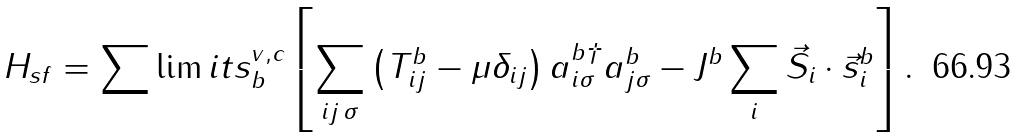<formula> <loc_0><loc_0><loc_500><loc_500>H _ { s f } = \sum \lim i t s _ { b } ^ { v , c } \left [ \sum _ { i j \, \sigma } \left ( T _ { i j } ^ { b } - \mu \delta _ { i j } \right ) a _ { i \sigma } ^ { b \dagger } a _ { j \sigma } ^ { b } - J ^ { b } \sum _ { i } \vec { S } _ { i } \cdot \vec { s } _ { i } ^ { b } \right ] .</formula> 